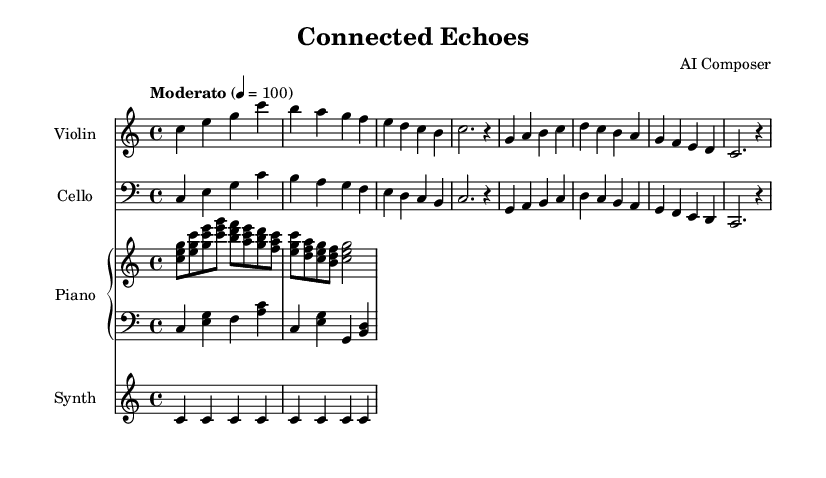What is the key signature of this music? The key signature is C major, which is indicated by the absence of sharps and flats on the staff.
Answer: C major What is the time signature of this composition? The time signature is indicated by the "4/4" marking, which means there are four beats in each measure.
Answer: 4/4 What is the tempo marking of the piece? The tempo marking "Moderato" and the metronome marking "4 = 100" indicate a moderate speed.
Answer: Moderato, 100 How many measures are there in the violin part? Count the segments divided by vertical lines (bars) in the violin part, which totals six measures.
Answer: 6 Which instrument has a clef indicating bass? The cello part has a bass clef specified at the beginning, signifying lower pitches are played.
Answer: Cello Describe the texture of the piano part. The piano part consists of two staves, with the right hand playing chords and the left playing bass notes, creating a rich texture.
Answer: Two-part texture What thematic element does the title "Connected Echoes" suggest? The title implies a focus on digital connectivity and interconnections, possibly reflecting social media's impact on communication.
Answer: Digital connectivity 